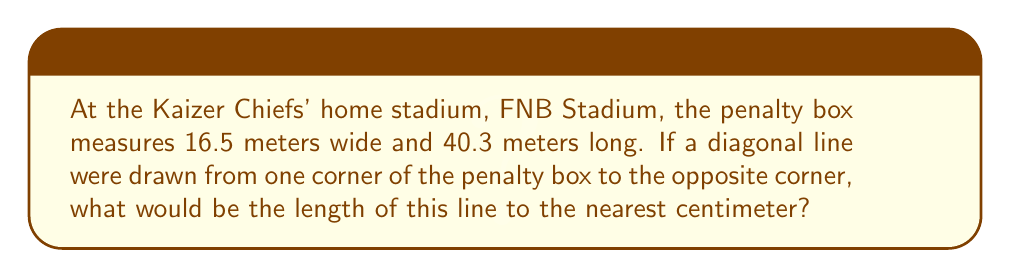Show me your answer to this math problem. Let's approach this step-by-step:

1) The penalty box forms a rectangle. The diagonal of a rectangle forms the hypotenuse of a right triangle.

2) We can use the Pythagorean theorem to find the length of the diagonal. Let's call the diagonal $d$.

3) According to the Pythagorean theorem:

   $$d^2 = 16.5^2 + 40.3^2$$

4) Let's calculate the right side:
   $$16.5^2 = 272.25$$
   $$40.3^2 = 1624.09$$

5) Adding these:
   $$d^2 = 272.25 + 1624.09 = 1896.34$$

6) To find $d$, we need to take the square root of both sides:
   $$d = \sqrt{1896.34}$$

7) Using a calculator:
   $$d \approx 43.5470$$

8) Rounding to the nearest centimeter:
   $$d \approx 43.55 \text{ meters}$$

[asy]
unitsize(4mm);
draw((0,0)--(16.5,0)--(16.5,40.3)--(0,40.3)--cycle);
draw((0,0)--(16.5,40.3),red);
label("16.5 m",(8.25,0),S);
label("40.3 m",(16.5,20.15),E);
label("d",(8.25,20.15),NW,red);
[/asy]
Answer: 43.55 meters 